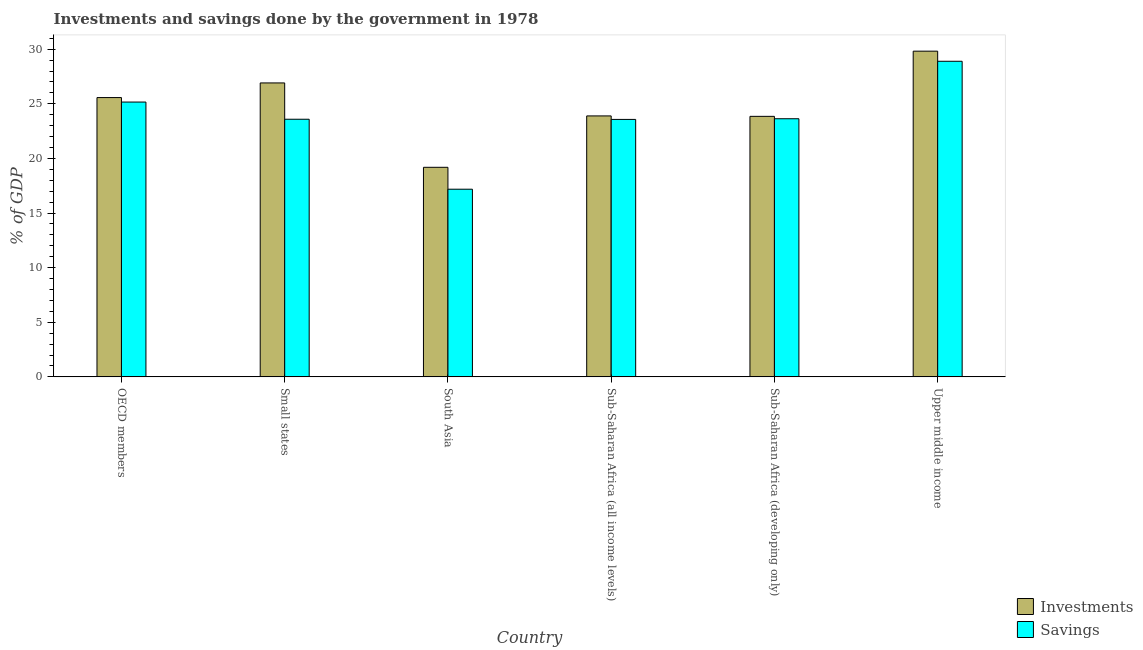How many groups of bars are there?
Offer a terse response. 6. How many bars are there on the 5th tick from the left?
Provide a succinct answer. 2. What is the label of the 2nd group of bars from the left?
Provide a short and direct response. Small states. What is the savings of government in Sub-Saharan Africa (all income levels)?
Make the answer very short. 23.57. Across all countries, what is the maximum savings of government?
Your answer should be compact. 28.89. Across all countries, what is the minimum savings of government?
Ensure brevity in your answer.  17.18. In which country was the savings of government maximum?
Provide a succinct answer. Upper middle income. What is the total investments of government in the graph?
Your answer should be very brief. 149.24. What is the difference between the savings of government in Small states and that in Upper middle income?
Your response must be concise. -5.31. What is the difference between the savings of government in Small states and the investments of government in South Asia?
Provide a succinct answer. 4.4. What is the average investments of government per country?
Your response must be concise. 24.87. What is the difference between the investments of government and savings of government in Sub-Saharan Africa (all income levels)?
Keep it short and to the point. 0.32. What is the ratio of the savings of government in OECD members to that in Sub-Saharan Africa (all income levels)?
Offer a very short reply. 1.07. What is the difference between the highest and the second highest savings of government?
Provide a succinct answer. 3.73. What is the difference between the highest and the lowest investments of government?
Your answer should be very brief. 10.63. What does the 1st bar from the left in Sub-Saharan Africa (all income levels) represents?
Give a very brief answer. Investments. What does the 2nd bar from the right in South Asia represents?
Keep it short and to the point. Investments. Does the graph contain grids?
Offer a terse response. No. How many legend labels are there?
Give a very brief answer. 2. What is the title of the graph?
Ensure brevity in your answer.  Investments and savings done by the government in 1978. Does "Foreign Liabilities" appear as one of the legend labels in the graph?
Provide a short and direct response. No. What is the label or title of the Y-axis?
Make the answer very short. % of GDP. What is the % of GDP in Investments in OECD members?
Your answer should be compact. 25.57. What is the % of GDP in Savings in OECD members?
Provide a short and direct response. 25.16. What is the % of GDP of Investments in Small states?
Your answer should be very brief. 26.91. What is the % of GDP of Savings in Small states?
Keep it short and to the point. 23.59. What is the % of GDP of Investments in South Asia?
Ensure brevity in your answer.  19.19. What is the % of GDP in Savings in South Asia?
Offer a very short reply. 17.18. What is the % of GDP in Investments in Sub-Saharan Africa (all income levels)?
Provide a succinct answer. 23.89. What is the % of GDP in Savings in Sub-Saharan Africa (all income levels)?
Provide a short and direct response. 23.57. What is the % of GDP of Investments in Sub-Saharan Africa (developing only)?
Offer a terse response. 23.85. What is the % of GDP of Savings in Sub-Saharan Africa (developing only)?
Your answer should be very brief. 23.63. What is the % of GDP of Investments in Upper middle income?
Make the answer very short. 29.82. What is the % of GDP of Savings in Upper middle income?
Offer a terse response. 28.89. Across all countries, what is the maximum % of GDP in Investments?
Offer a terse response. 29.82. Across all countries, what is the maximum % of GDP in Savings?
Provide a succinct answer. 28.89. Across all countries, what is the minimum % of GDP in Investments?
Offer a very short reply. 19.19. Across all countries, what is the minimum % of GDP of Savings?
Your answer should be compact. 17.18. What is the total % of GDP in Investments in the graph?
Ensure brevity in your answer.  149.24. What is the total % of GDP in Savings in the graph?
Provide a succinct answer. 142.03. What is the difference between the % of GDP in Investments in OECD members and that in Small states?
Provide a succinct answer. -1.34. What is the difference between the % of GDP in Savings in OECD members and that in Small states?
Keep it short and to the point. 1.57. What is the difference between the % of GDP in Investments in OECD members and that in South Asia?
Make the answer very short. 6.38. What is the difference between the % of GDP of Savings in OECD members and that in South Asia?
Provide a succinct answer. 7.98. What is the difference between the % of GDP of Investments in OECD members and that in Sub-Saharan Africa (all income levels)?
Your answer should be very brief. 1.68. What is the difference between the % of GDP of Savings in OECD members and that in Sub-Saharan Africa (all income levels)?
Make the answer very short. 1.59. What is the difference between the % of GDP in Investments in OECD members and that in Sub-Saharan Africa (developing only)?
Your answer should be compact. 1.72. What is the difference between the % of GDP in Savings in OECD members and that in Sub-Saharan Africa (developing only)?
Offer a very short reply. 1.53. What is the difference between the % of GDP in Investments in OECD members and that in Upper middle income?
Provide a succinct answer. -4.25. What is the difference between the % of GDP in Savings in OECD members and that in Upper middle income?
Keep it short and to the point. -3.73. What is the difference between the % of GDP of Investments in Small states and that in South Asia?
Ensure brevity in your answer.  7.72. What is the difference between the % of GDP in Savings in Small states and that in South Asia?
Your response must be concise. 6.4. What is the difference between the % of GDP of Investments in Small states and that in Sub-Saharan Africa (all income levels)?
Your answer should be compact. 3.02. What is the difference between the % of GDP of Savings in Small states and that in Sub-Saharan Africa (all income levels)?
Your response must be concise. 0.02. What is the difference between the % of GDP in Investments in Small states and that in Sub-Saharan Africa (developing only)?
Give a very brief answer. 3.06. What is the difference between the % of GDP in Savings in Small states and that in Sub-Saharan Africa (developing only)?
Provide a succinct answer. -0.05. What is the difference between the % of GDP of Investments in Small states and that in Upper middle income?
Offer a very short reply. -2.91. What is the difference between the % of GDP of Savings in Small states and that in Upper middle income?
Ensure brevity in your answer.  -5.31. What is the difference between the % of GDP in Investments in South Asia and that in Sub-Saharan Africa (all income levels)?
Keep it short and to the point. -4.71. What is the difference between the % of GDP of Savings in South Asia and that in Sub-Saharan Africa (all income levels)?
Offer a very short reply. -6.39. What is the difference between the % of GDP of Investments in South Asia and that in Sub-Saharan Africa (developing only)?
Your answer should be compact. -4.67. What is the difference between the % of GDP in Savings in South Asia and that in Sub-Saharan Africa (developing only)?
Your answer should be compact. -6.45. What is the difference between the % of GDP of Investments in South Asia and that in Upper middle income?
Offer a terse response. -10.63. What is the difference between the % of GDP of Savings in South Asia and that in Upper middle income?
Make the answer very short. -11.71. What is the difference between the % of GDP in Investments in Sub-Saharan Africa (all income levels) and that in Sub-Saharan Africa (developing only)?
Keep it short and to the point. 0.04. What is the difference between the % of GDP of Savings in Sub-Saharan Africa (all income levels) and that in Sub-Saharan Africa (developing only)?
Your answer should be very brief. -0.06. What is the difference between the % of GDP in Investments in Sub-Saharan Africa (all income levels) and that in Upper middle income?
Provide a succinct answer. -5.93. What is the difference between the % of GDP of Savings in Sub-Saharan Africa (all income levels) and that in Upper middle income?
Provide a short and direct response. -5.32. What is the difference between the % of GDP in Investments in Sub-Saharan Africa (developing only) and that in Upper middle income?
Provide a succinct answer. -5.97. What is the difference between the % of GDP in Savings in Sub-Saharan Africa (developing only) and that in Upper middle income?
Your answer should be very brief. -5.26. What is the difference between the % of GDP of Investments in OECD members and the % of GDP of Savings in Small states?
Make the answer very short. 1.98. What is the difference between the % of GDP of Investments in OECD members and the % of GDP of Savings in South Asia?
Your answer should be very brief. 8.39. What is the difference between the % of GDP in Investments in OECD members and the % of GDP in Savings in Sub-Saharan Africa (all income levels)?
Offer a very short reply. 2. What is the difference between the % of GDP in Investments in OECD members and the % of GDP in Savings in Sub-Saharan Africa (developing only)?
Your response must be concise. 1.94. What is the difference between the % of GDP of Investments in OECD members and the % of GDP of Savings in Upper middle income?
Your answer should be very brief. -3.32. What is the difference between the % of GDP of Investments in Small states and the % of GDP of Savings in South Asia?
Offer a terse response. 9.73. What is the difference between the % of GDP in Investments in Small states and the % of GDP in Savings in Sub-Saharan Africa (all income levels)?
Provide a succinct answer. 3.34. What is the difference between the % of GDP in Investments in Small states and the % of GDP in Savings in Sub-Saharan Africa (developing only)?
Provide a short and direct response. 3.28. What is the difference between the % of GDP of Investments in Small states and the % of GDP of Savings in Upper middle income?
Provide a short and direct response. -1.98. What is the difference between the % of GDP of Investments in South Asia and the % of GDP of Savings in Sub-Saharan Africa (all income levels)?
Keep it short and to the point. -4.38. What is the difference between the % of GDP in Investments in South Asia and the % of GDP in Savings in Sub-Saharan Africa (developing only)?
Your answer should be very brief. -4.45. What is the difference between the % of GDP of Investments in South Asia and the % of GDP of Savings in Upper middle income?
Keep it short and to the point. -9.71. What is the difference between the % of GDP in Investments in Sub-Saharan Africa (all income levels) and the % of GDP in Savings in Sub-Saharan Africa (developing only)?
Give a very brief answer. 0.26. What is the difference between the % of GDP of Investments in Sub-Saharan Africa (all income levels) and the % of GDP of Savings in Upper middle income?
Keep it short and to the point. -5. What is the difference between the % of GDP of Investments in Sub-Saharan Africa (developing only) and the % of GDP of Savings in Upper middle income?
Provide a short and direct response. -5.04. What is the average % of GDP of Investments per country?
Keep it short and to the point. 24.87. What is the average % of GDP of Savings per country?
Your answer should be compact. 23.67. What is the difference between the % of GDP of Investments and % of GDP of Savings in OECD members?
Provide a succinct answer. 0.41. What is the difference between the % of GDP in Investments and % of GDP in Savings in Small states?
Offer a terse response. 3.33. What is the difference between the % of GDP in Investments and % of GDP in Savings in South Asia?
Ensure brevity in your answer.  2.01. What is the difference between the % of GDP in Investments and % of GDP in Savings in Sub-Saharan Africa (all income levels)?
Provide a short and direct response. 0.32. What is the difference between the % of GDP of Investments and % of GDP of Savings in Sub-Saharan Africa (developing only)?
Your response must be concise. 0.22. What is the difference between the % of GDP of Investments and % of GDP of Savings in Upper middle income?
Give a very brief answer. 0.93. What is the ratio of the % of GDP in Investments in OECD members to that in Small states?
Provide a short and direct response. 0.95. What is the ratio of the % of GDP in Savings in OECD members to that in Small states?
Provide a succinct answer. 1.07. What is the ratio of the % of GDP of Investments in OECD members to that in South Asia?
Make the answer very short. 1.33. What is the ratio of the % of GDP of Savings in OECD members to that in South Asia?
Ensure brevity in your answer.  1.46. What is the ratio of the % of GDP in Investments in OECD members to that in Sub-Saharan Africa (all income levels)?
Provide a succinct answer. 1.07. What is the ratio of the % of GDP in Savings in OECD members to that in Sub-Saharan Africa (all income levels)?
Give a very brief answer. 1.07. What is the ratio of the % of GDP in Investments in OECD members to that in Sub-Saharan Africa (developing only)?
Your answer should be compact. 1.07. What is the ratio of the % of GDP in Savings in OECD members to that in Sub-Saharan Africa (developing only)?
Offer a terse response. 1.06. What is the ratio of the % of GDP in Investments in OECD members to that in Upper middle income?
Provide a succinct answer. 0.86. What is the ratio of the % of GDP of Savings in OECD members to that in Upper middle income?
Offer a very short reply. 0.87. What is the ratio of the % of GDP in Investments in Small states to that in South Asia?
Your answer should be very brief. 1.4. What is the ratio of the % of GDP in Savings in Small states to that in South Asia?
Make the answer very short. 1.37. What is the ratio of the % of GDP of Investments in Small states to that in Sub-Saharan Africa (all income levels)?
Keep it short and to the point. 1.13. What is the ratio of the % of GDP of Investments in Small states to that in Sub-Saharan Africa (developing only)?
Offer a terse response. 1.13. What is the ratio of the % of GDP of Savings in Small states to that in Sub-Saharan Africa (developing only)?
Give a very brief answer. 1. What is the ratio of the % of GDP in Investments in Small states to that in Upper middle income?
Offer a very short reply. 0.9. What is the ratio of the % of GDP in Savings in Small states to that in Upper middle income?
Offer a terse response. 0.82. What is the ratio of the % of GDP in Investments in South Asia to that in Sub-Saharan Africa (all income levels)?
Your response must be concise. 0.8. What is the ratio of the % of GDP of Savings in South Asia to that in Sub-Saharan Africa (all income levels)?
Ensure brevity in your answer.  0.73. What is the ratio of the % of GDP of Investments in South Asia to that in Sub-Saharan Africa (developing only)?
Give a very brief answer. 0.8. What is the ratio of the % of GDP in Savings in South Asia to that in Sub-Saharan Africa (developing only)?
Offer a terse response. 0.73. What is the ratio of the % of GDP of Investments in South Asia to that in Upper middle income?
Offer a terse response. 0.64. What is the ratio of the % of GDP of Savings in South Asia to that in Upper middle income?
Offer a very short reply. 0.59. What is the ratio of the % of GDP in Investments in Sub-Saharan Africa (all income levels) to that in Sub-Saharan Africa (developing only)?
Give a very brief answer. 1. What is the ratio of the % of GDP in Investments in Sub-Saharan Africa (all income levels) to that in Upper middle income?
Offer a very short reply. 0.8. What is the ratio of the % of GDP of Savings in Sub-Saharan Africa (all income levels) to that in Upper middle income?
Keep it short and to the point. 0.82. What is the ratio of the % of GDP of Investments in Sub-Saharan Africa (developing only) to that in Upper middle income?
Keep it short and to the point. 0.8. What is the ratio of the % of GDP of Savings in Sub-Saharan Africa (developing only) to that in Upper middle income?
Your answer should be very brief. 0.82. What is the difference between the highest and the second highest % of GDP of Investments?
Ensure brevity in your answer.  2.91. What is the difference between the highest and the second highest % of GDP of Savings?
Your answer should be very brief. 3.73. What is the difference between the highest and the lowest % of GDP in Investments?
Make the answer very short. 10.63. What is the difference between the highest and the lowest % of GDP in Savings?
Your answer should be compact. 11.71. 